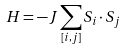Convert formula to latex. <formula><loc_0><loc_0><loc_500><loc_500>H = - J \sum _ { [ i , j ] } S _ { i } \cdot S _ { j }</formula> 